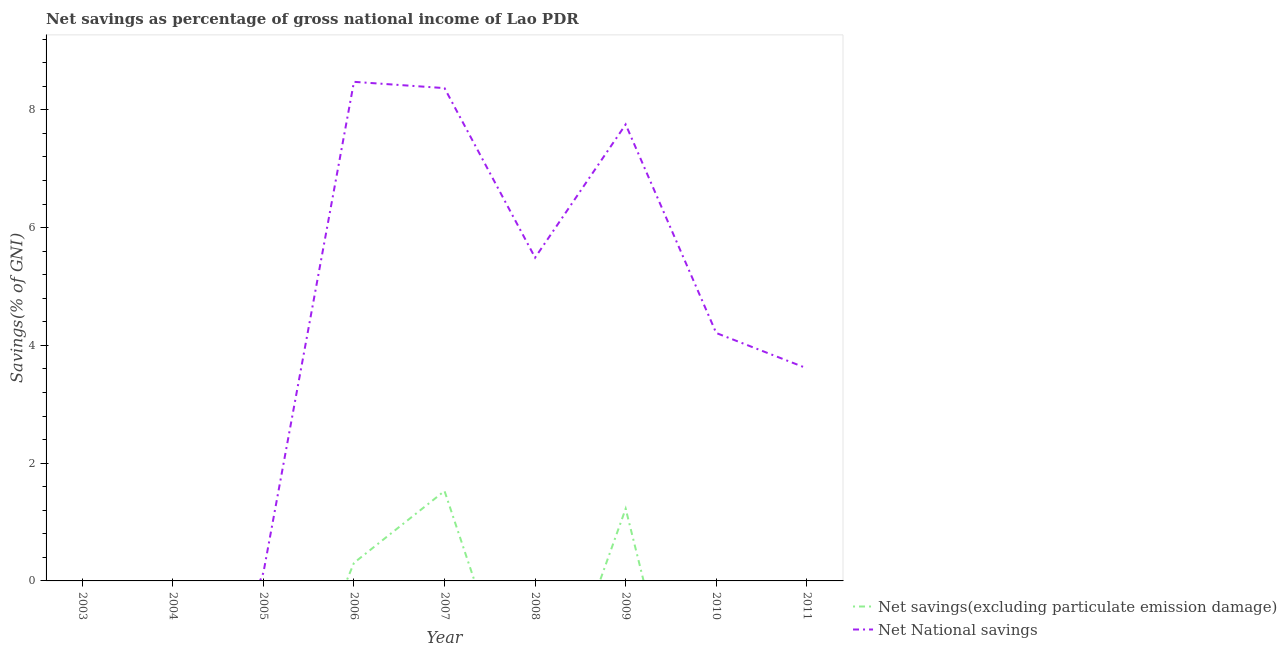How many different coloured lines are there?
Keep it short and to the point. 2. Is the number of lines equal to the number of legend labels?
Give a very brief answer. No. Across all years, what is the maximum net savings(excluding particulate emission damage)?
Your response must be concise. 1.53. Across all years, what is the minimum net savings(excluding particulate emission damage)?
Offer a terse response. 0. What is the total net savings(excluding particulate emission damage) in the graph?
Provide a short and direct response. 3.06. What is the difference between the net national savings in 2006 and that in 2010?
Your answer should be very brief. 4.27. What is the difference between the net national savings in 2011 and the net savings(excluding particulate emission damage) in 2010?
Ensure brevity in your answer.  3.61. What is the average net savings(excluding particulate emission damage) per year?
Offer a very short reply. 0.34. In the year 2009, what is the difference between the net savings(excluding particulate emission damage) and net national savings?
Your answer should be compact. -6.53. In how many years, is the net savings(excluding particulate emission damage) greater than 1.2000000000000002 %?
Ensure brevity in your answer.  2. What is the ratio of the net national savings in 2009 to that in 2010?
Keep it short and to the point. 1.84. What is the difference between the highest and the second highest net national savings?
Provide a short and direct response. 0.11. What is the difference between the highest and the lowest net national savings?
Make the answer very short. 8.48. How many years are there in the graph?
Give a very brief answer. 9. What is the difference between two consecutive major ticks on the Y-axis?
Your answer should be very brief. 2. Does the graph contain any zero values?
Offer a very short reply. Yes. Where does the legend appear in the graph?
Keep it short and to the point. Bottom right. How many legend labels are there?
Provide a succinct answer. 2. What is the title of the graph?
Offer a very short reply. Net savings as percentage of gross national income of Lao PDR. What is the label or title of the X-axis?
Provide a short and direct response. Year. What is the label or title of the Y-axis?
Make the answer very short. Savings(% of GNI). What is the Savings(% of GNI) of Net savings(excluding particulate emission damage) in 2003?
Ensure brevity in your answer.  0. What is the Savings(% of GNI) in Net savings(excluding particulate emission damage) in 2005?
Ensure brevity in your answer.  0. What is the Savings(% of GNI) of Net National savings in 2005?
Offer a very short reply. 0.14. What is the Savings(% of GNI) in Net savings(excluding particulate emission damage) in 2006?
Provide a succinct answer. 0.31. What is the Savings(% of GNI) in Net National savings in 2006?
Give a very brief answer. 8.48. What is the Savings(% of GNI) of Net savings(excluding particulate emission damage) in 2007?
Ensure brevity in your answer.  1.53. What is the Savings(% of GNI) of Net National savings in 2007?
Make the answer very short. 8.37. What is the Savings(% of GNI) of Net savings(excluding particulate emission damage) in 2008?
Keep it short and to the point. 0. What is the Savings(% of GNI) in Net National savings in 2008?
Offer a terse response. 5.49. What is the Savings(% of GNI) of Net savings(excluding particulate emission damage) in 2009?
Keep it short and to the point. 1.23. What is the Savings(% of GNI) of Net National savings in 2009?
Offer a terse response. 7.75. What is the Savings(% of GNI) of Net savings(excluding particulate emission damage) in 2010?
Keep it short and to the point. 0. What is the Savings(% of GNI) of Net National savings in 2010?
Ensure brevity in your answer.  4.21. What is the Savings(% of GNI) in Net savings(excluding particulate emission damage) in 2011?
Your answer should be very brief. 0. What is the Savings(% of GNI) of Net National savings in 2011?
Provide a short and direct response. 3.61. Across all years, what is the maximum Savings(% of GNI) of Net savings(excluding particulate emission damage)?
Provide a short and direct response. 1.53. Across all years, what is the maximum Savings(% of GNI) of Net National savings?
Your answer should be very brief. 8.48. Across all years, what is the minimum Savings(% of GNI) of Net savings(excluding particulate emission damage)?
Your answer should be compact. 0. What is the total Savings(% of GNI) of Net savings(excluding particulate emission damage) in the graph?
Provide a succinct answer. 3.06. What is the total Savings(% of GNI) of Net National savings in the graph?
Your response must be concise. 38.05. What is the difference between the Savings(% of GNI) in Net National savings in 2005 and that in 2006?
Your answer should be compact. -8.34. What is the difference between the Savings(% of GNI) of Net National savings in 2005 and that in 2007?
Ensure brevity in your answer.  -8.23. What is the difference between the Savings(% of GNI) in Net National savings in 2005 and that in 2008?
Keep it short and to the point. -5.35. What is the difference between the Savings(% of GNI) in Net National savings in 2005 and that in 2009?
Give a very brief answer. -7.61. What is the difference between the Savings(% of GNI) in Net National savings in 2005 and that in 2010?
Provide a short and direct response. -4.07. What is the difference between the Savings(% of GNI) in Net National savings in 2005 and that in 2011?
Provide a short and direct response. -3.47. What is the difference between the Savings(% of GNI) in Net savings(excluding particulate emission damage) in 2006 and that in 2007?
Provide a short and direct response. -1.22. What is the difference between the Savings(% of GNI) of Net National savings in 2006 and that in 2007?
Your answer should be compact. 0.11. What is the difference between the Savings(% of GNI) of Net National savings in 2006 and that in 2008?
Provide a succinct answer. 2.99. What is the difference between the Savings(% of GNI) of Net savings(excluding particulate emission damage) in 2006 and that in 2009?
Your answer should be compact. -0.92. What is the difference between the Savings(% of GNI) in Net National savings in 2006 and that in 2009?
Your response must be concise. 0.72. What is the difference between the Savings(% of GNI) in Net National savings in 2006 and that in 2010?
Your answer should be very brief. 4.27. What is the difference between the Savings(% of GNI) of Net National savings in 2006 and that in 2011?
Ensure brevity in your answer.  4.86. What is the difference between the Savings(% of GNI) of Net National savings in 2007 and that in 2008?
Provide a short and direct response. 2.88. What is the difference between the Savings(% of GNI) of Net savings(excluding particulate emission damage) in 2007 and that in 2009?
Provide a succinct answer. 0.3. What is the difference between the Savings(% of GNI) in Net National savings in 2007 and that in 2009?
Provide a succinct answer. 0.62. What is the difference between the Savings(% of GNI) of Net National savings in 2007 and that in 2010?
Provide a succinct answer. 4.16. What is the difference between the Savings(% of GNI) in Net National savings in 2007 and that in 2011?
Offer a very short reply. 4.76. What is the difference between the Savings(% of GNI) of Net National savings in 2008 and that in 2009?
Your answer should be compact. -2.26. What is the difference between the Savings(% of GNI) of Net National savings in 2008 and that in 2010?
Offer a very short reply. 1.28. What is the difference between the Savings(% of GNI) of Net National savings in 2008 and that in 2011?
Provide a short and direct response. 1.88. What is the difference between the Savings(% of GNI) of Net National savings in 2009 and that in 2010?
Give a very brief answer. 3.54. What is the difference between the Savings(% of GNI) in Net National savings in 2009 and that in 2011?
Your answer should be very brief. 4.14. What is the difference between the Savings(% of GNI) of Net National savings in 2010 and that in 2011?
Offer a very short reply. 0.6. What is the difference between the Savings(% of GNI) of Net savings(excluding particulate emission damage) in 2006 and the Savings(% of GNI) of Net National savings in 2007?
Give a very brief answer. -8.06. What is the difference between the Savings(% of GNI) in Net savings(excluding particulate emission damage) in 2006 and the Savings(% of GNI) in Net National savings in 2008?
Keep it short and to the point. -5.18. What is the difference between the Savings(% of GNI) of Net savings(excluding particulate emission damage) in 2006 and the Savings(% of GNI) of Net National savings in 2009?
Provide a succinct answer. -7.45. What is the difference between the Savings(% of GNI) in Net savings(excluding particulate emission damage) in 2006 and the Savings(% of GNI) in Net National savings in 2010?
Your answer should be compact. -3.9. What is the difference between the Savings(% of GNI) of Net savings(excluding particulate emission damage) in 2006 and the Savings(% of GNI) of Net National savings in 2011?
Ensure brevity in your answer.  -3.3. What is the difference between the Savings(% of GNI) of Net savings(excluding particulate emission damage) in 2007 and the Savings(% of GNI) of Net National savings in 2008?
Keep it short and to the point. -3.96. What is the difference between the Savings(% of GNI) in Net savings(excluding particulate emission damage) in 2007 and the Savings(% of GNI) in Net National savings in 2009?
Give a very brief answer. -6.23. What is the difference between the Savings(% of GNI) in Net savings(excluding particulate emission damage) in 2007 and the Savings(% of GNI) in Net National savings in 2010?
Offer a terse response. -2.68. What is the difference between the Savings(% of GNI) of Net savings(excluding particulate emission damage) in 2007 and the Savings(% of GNI) of Net National savings in 2011?
Keep it short and to the point. -2.08. What is the difference between the Savings(% of GNI) in Net savings(excluding particulate emission damage) in 2009 and the Savings(% of GNI) in Net National savings in 2010?
Keep it short and to the point. -2.98. What is the difference between the Savings(% of GNI) in Net savings(excluding particulate emission damage) in 2009 and the Savings(% of GNI) in Net National savings in 2011?
Your response must be concise. -2.38. What is the average Savings(% of GNI) of Net savings(excluding particulate emission damage) per year?
Offer a terse response. 0.34. What is the average Savings(% of GNI) of Net National savings per year?
Offer a very short reply. 4.23. In the year 2006, what is the difference between the Savings(% of GNI) of Net savings(excluding particulate emission damage) and Savings(% of GNI) of Net National savings?
Make the answer very short. -8.17. In the year 2007, what is the difference between the Savings(% of GNI) in Net savings(excluding particulate emission damage) and Savings(% of GNI) in Net National savings?
Give a very brief answer. -6.84. In the year 2009, what is the difference between the Savings(% of GNI) of Net savings(excluding particulate emission damage) and Savings(% of GNI) of Net National savings?
Offer a very short reply. -6.53. What is the ratio of the Savings(% of GNI) in Net National savings in 2005 to that in 2006?
Provide a succinct answer. 0.02. What is the ratio of the Savings(% of GNI) of Net National savings in 2005 to that in 2007?
Make the answer very short. 0.02. What is the ratio of the Savings(% of GNI) in Net National savings in 2005 to that in 2008?
Provide a short and direct response. 0.03. What is the ratio of the Savings(% of GNI) of Net National savings in 2005 to that in 2009?
Provide a succinct answer. 0.02. What is the ratio of the Savings(% of GNI) in Net National savings in 2005 to that in 2010?
Provide a succinct answer. 0.03. What is the ratio of the Savings(% of GNI) in Net National savings in 2005 to that in 2011?
Make the answer very short. 0.04. What is the ratio of the Savings(% of GNI) of Net savings(excluding particulate emission damage) in 2006 to that in 2007?
Keep it short and to the point. 0.2. What is the ratio of the Savings(% of GNI) of Net National savings in 2006 to that in 2007?
Give a very brief answer. 1.01. What is the ratio of the Savings(% of GNI) of Net National savings in 2006 to that in 2008?
Provide a short and direct response. 1.54. What is the ratio of the Savings(% of GNI) in Net National savings in 2006 to that in 2009?
Ensure brevity in your answer.  1.09. What is the ratio of the Savings(% of GNI) in Net National savings in 2006 to that in 2010?
Ensure brevity in your answer.  2.01. What is the ratio of the Savings(% of GNI) of Net National savings in 2006 to that in 2011?
Keep it short and to the point. 2.35. What is the ratio of the Savings(% of GNI) of Net National savings in 2007 to that in 2008?
Offer a terse response. 1.52. What is the ratio of the Savings(% of GNI) in Net savings(excluding particulate emission damage) in 2007 to that in 2009?
Ensure brevity in your answer.  1.25. What is the ratio of the Savings(% of GNI) in Net National savings in 2007 to that in 2009?
Your answer should be very brief. 1.08. What is the ratio of the Savings(% of GNI) in Net National savings in 2007 to that in 2010?
Make the answer very short. 1.99. What is the ratio of the Savings(% of GNI) of Net National savings in 2007 to that in 2011?
Your answer should be compact. 2.32. What is the ratio of the Savings(% of GNI) in Net National savings in 2008 to that in 2009?
Give a very brief answer. 0.71. What is the ratio of the Savings(% of GNI) in Net National savings in 2008 to that in 2010?
Keep it short and to the point. 1.3. What is the ratio of the Savings(% of GNI) in Net National savings in 2008 to that in 2011?
Offer a terse response. 1.52. What is the ratio of the Savings(% of GNI) of Net National savings in 2009 to that in 2010?
Your response must be concise. 1.84. What is the ratio of the Savings(% of GNI) of Net National savings in 2009 to that in 2011?
Keep it short and to the point. 2.15. What is the ratio of the Savings(% of GNI) of Net National savings in 2010 to that in 2011?
Your answer should be compact. 1.17. What is the difference between the highest and the second highest Savings(% of GNI) of Net savings(excluding particulate emission damage)?
Keep it short and to the point. 0.3. What is the difference between the highest and the second highest Savings(% of GNI) of Net National savings?
Offer a very short reply. 0.11. What is the difference between the highest and the lowest Savings(% of GNI) of Net savings(excluding particulate emission damage)?
Keep it short and to the point. 1.53. What is the difference between the highest and the lowest Savings(% of GNI) in Net National savings?
Make the answer very short. 8.48. 